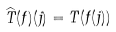Convert formula to latex. <formula><loc_0><loc_0><loc_500><loc_500>\widehat { T } ( f ) ( j ) = T ( f ( j ) )</formula> 